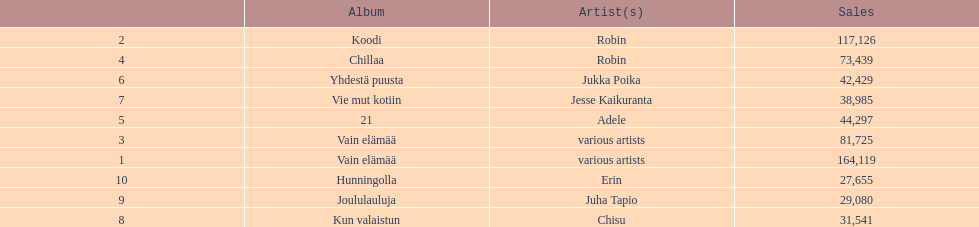What album is listed before 21? Chillaa. 